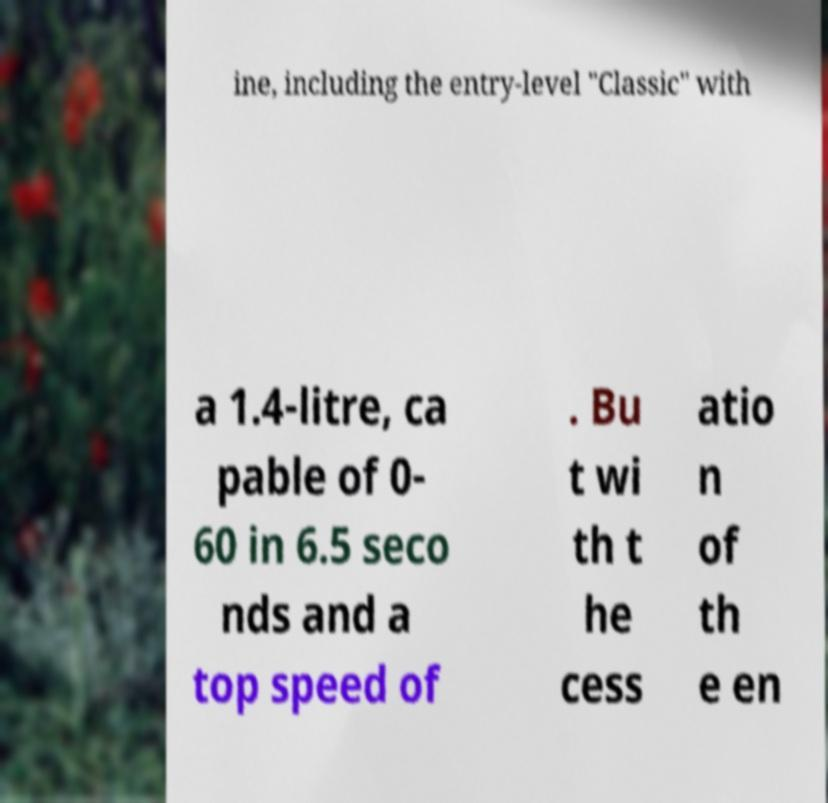Can you read and provide the text displayed in the image?This photo seems to have some interesting text. Can you extract and type it out for me? ine, including the entry-level "Classic" with a 1.4-litre, ca pable of 0- 60 in 6.5 seco nds and a top speed of . Bu t wi th t he cess atio n of th e en 